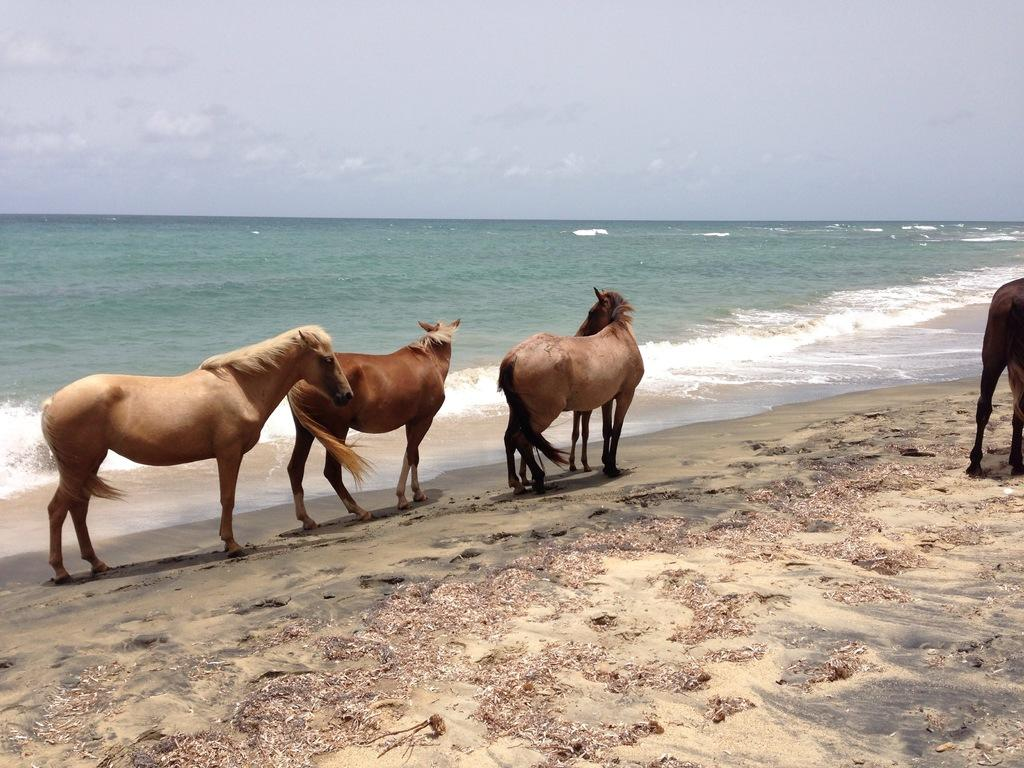What animals are present in the image? There are horses in the image. What direction are the horses walking in? The horses are walking towards the right. What type of environment is visible in the image? There is water visible in the image. Can you see any cribs or caves in the image? There are no cribs or caves present in the image. Are the horses displaying any fangs in the image? Horses do not have fangs, so there are no fangs visible in the image. 